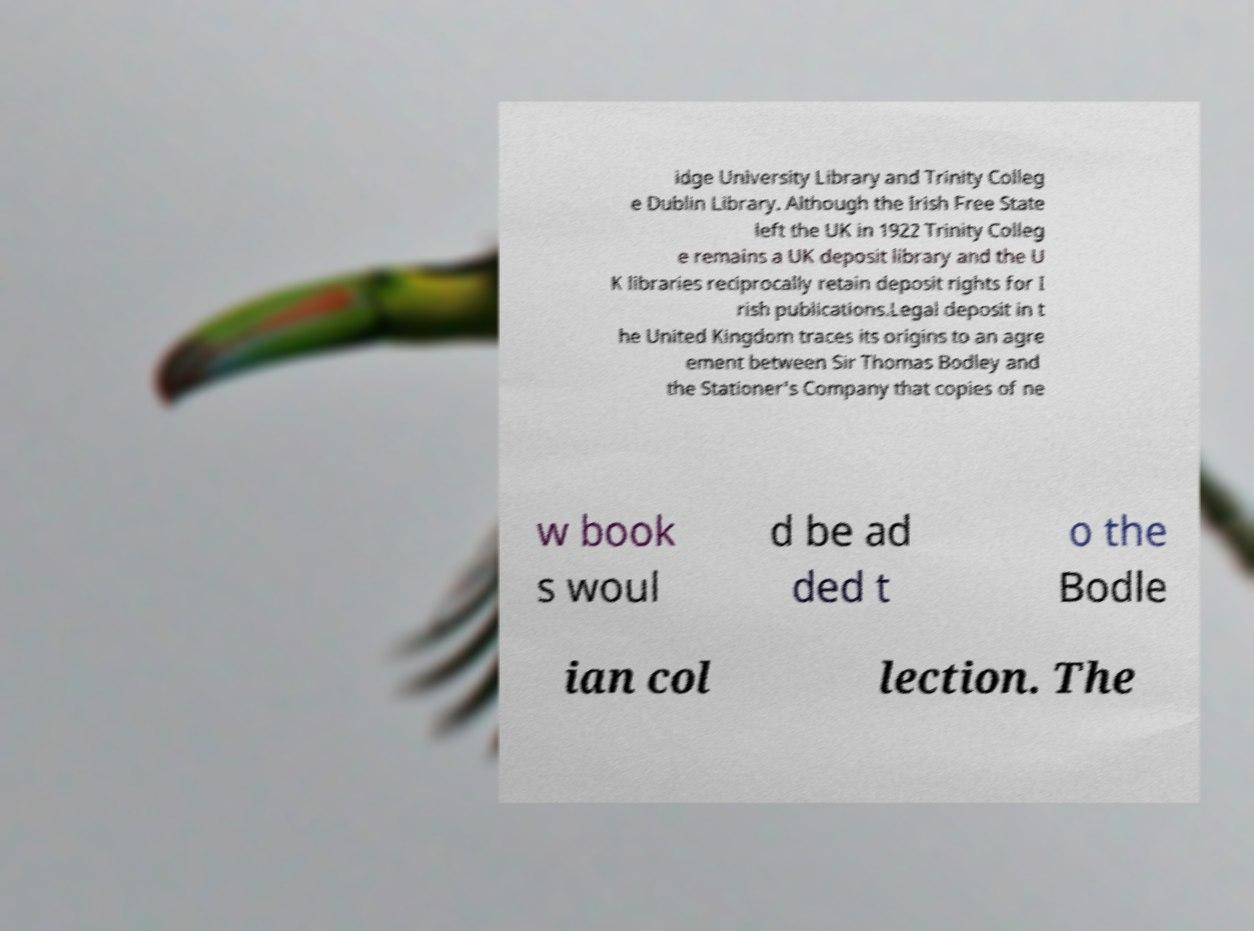For documentation purposes, I need the text within this image transcribed. Could you provide that? idge University Library and Trinity Colleg e Dublin Library. Although the Irish Free State left the UK in 1922 Trinity Colleg e remains a UK deposit library and the U K libraries reciprocally retain deposit rights for I rish publications.Legal deposit in t he United Kingdom traces its origins to an agre ement between Sir Thomas Bodley and the Stationer's Company that copies of ne w book s woul d be ad ded t o the Bodle ian col lection. The 